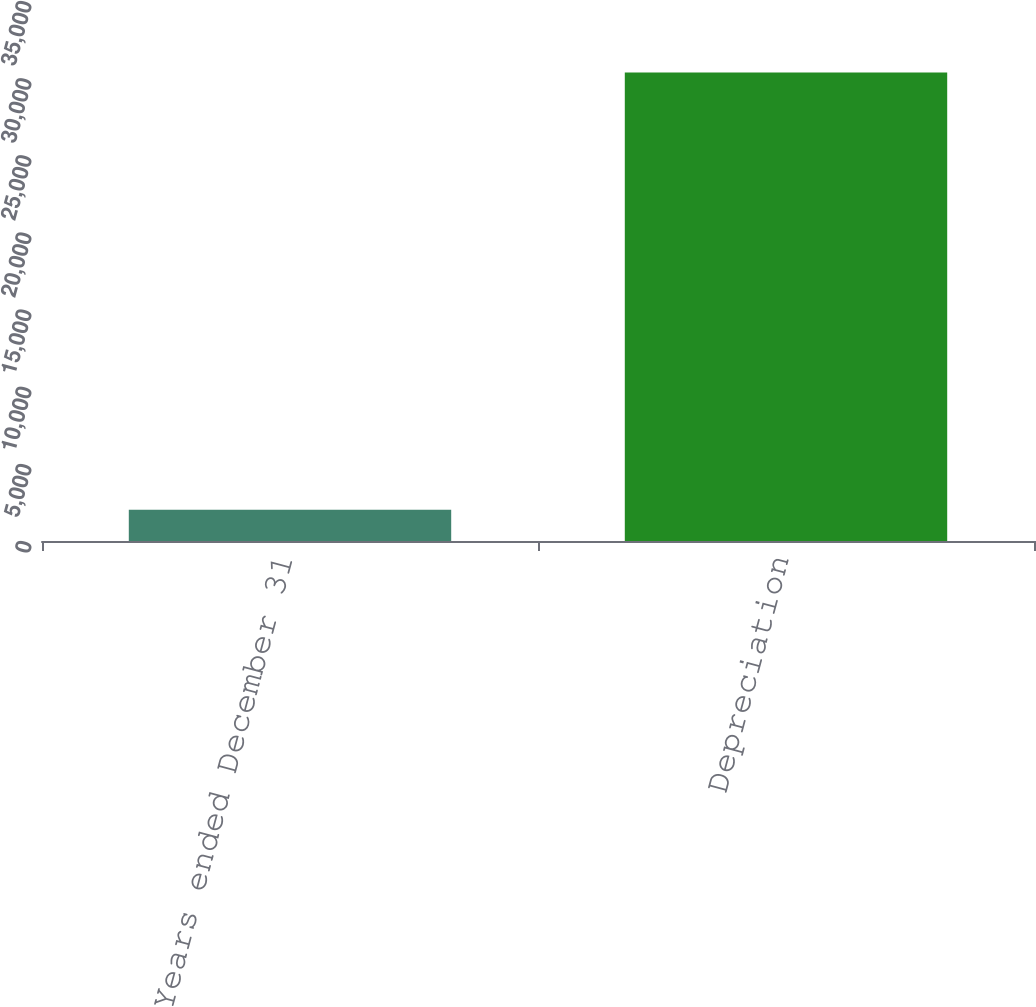<chart> <loc_0><loc_0><loc_500><loc_500><bar_chart><fcel>Years ended December 31<fcel>Depreciation<nl><fcel>2018<fcel>30364<nl></chart> 